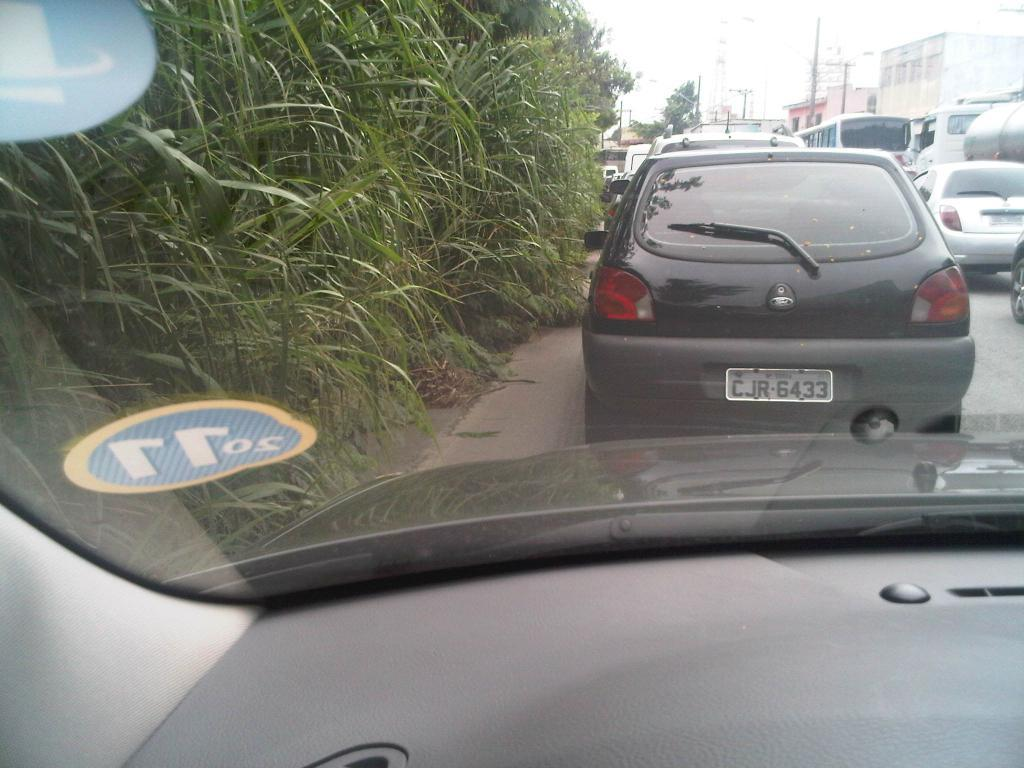<image>
Provide a brief description of the given image. A black Ford with the license plate CJR6433 next to some tall bushes. 